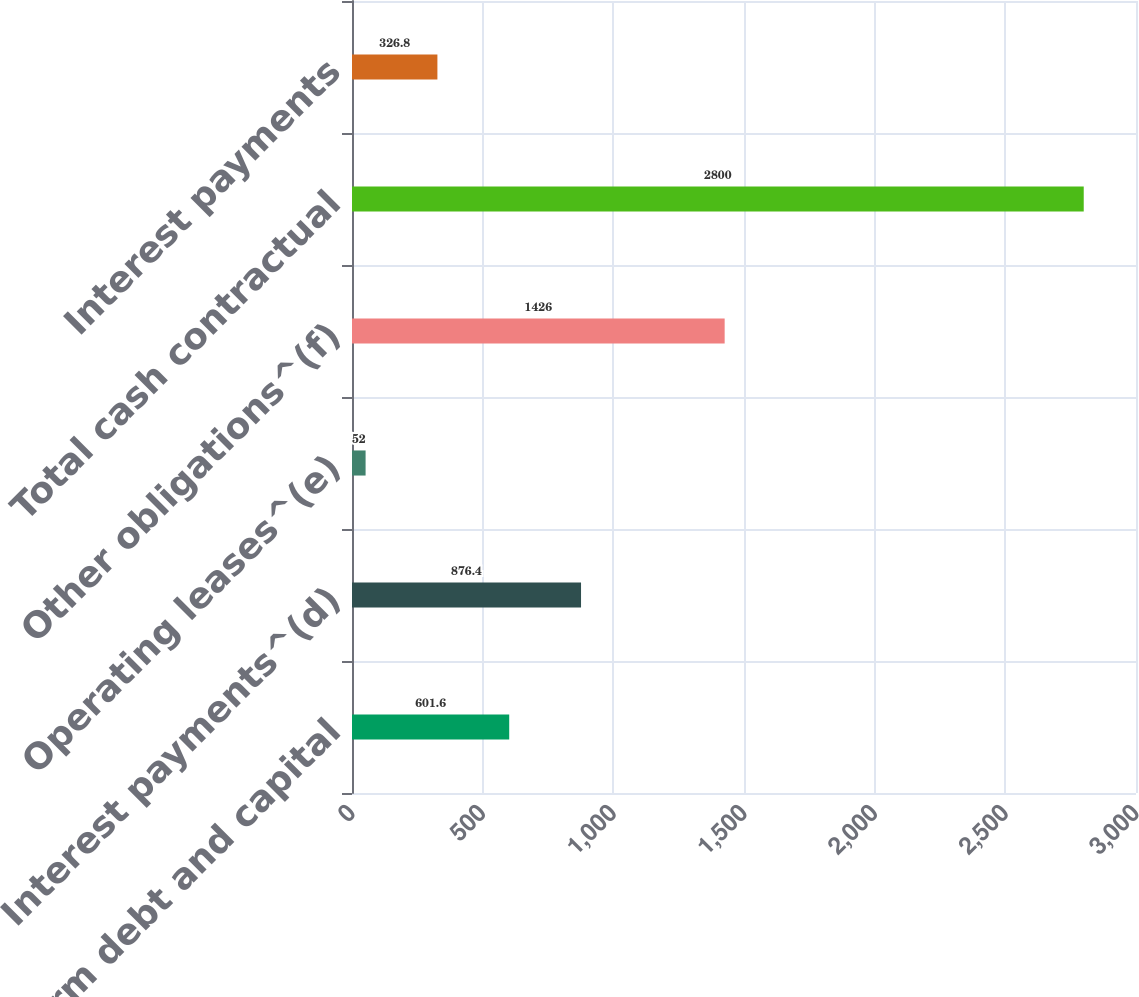<chart> <loc_0><loc_0><loc_500><loc_500><bar_chart><fcel>Long-term debt and capital<fcel>Interest payments^(d)<fcel>Operating leases^(e)<fcel>Other obligations^(f)<fcel>Total cash contractual<fcel>Interest payments<nl><fcel>601.6<fcel>876.4<fcel>52<fcel>1426<fcel>2800<fcel>326.8<nl></chart> 